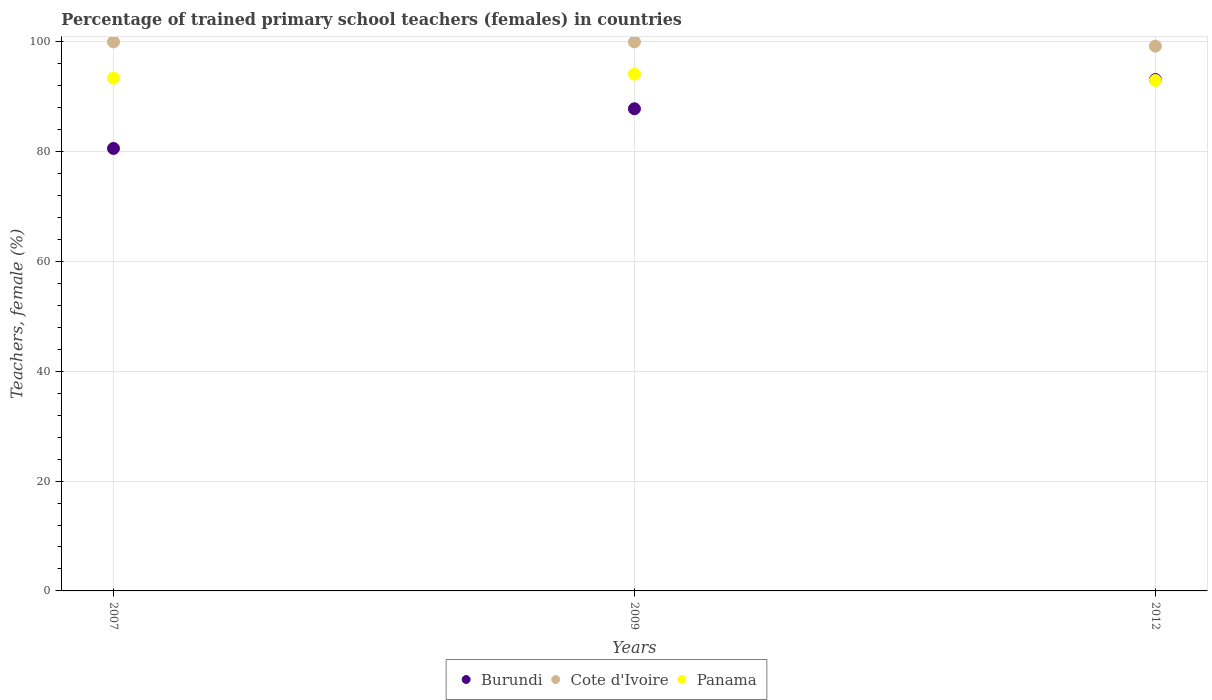How many different coloured dotlines are there?
Ensure brevity in your answer.  3. Is the number of dotlines equal to the number of legend labels?
Provide a short and direct response. Yes. What is the percentage of trained primary school teachers (females) in Panama in 2009?
Your response must be concise. 94.14. Across all years, what is the maximum percentage of trained primary school teachers (females) in Panama?
Give a very brief answer. 94.14. Across all years, what is the minimum percentage of trained primary school teachers (females) in Panama?
Keep it short and to the point. 92.97. In which year was the percentage of trained primary school teachers (females) in Burundi minimum?
Offer a very short reply. 2007. What is the total percentage of trained primary school teachers (females) in Cote d'Ivoire in the graph?
Give a very brief answer. 299.23. What is the difference between the percentage of trained primary school teachers (females) in Burundi in 2009 and that in 2012?
Your answer should be compact. -5.32. What is the difference between the percentage of trained primary school teachers (females) in Burundi in 2012 and the percentage of trained primary school teachers (females) in Panama in 2009?
Your response must be concise. -0.99. What is the average percentage of trained primary school teachers (females) in Panama per year?
Your response must be concise. 93.5. In the year 2012, what is the difference between the percentage of trained primary school teachers (females) in Burundi and percentage of trained primary school teachers (females) in Panama?
Ensure brevity in your answer.  0.18. In how many years, is the percentage of trained primary school teachers (females) in Panama greater than 48 %?
Your answer should be compact. 3. What is the ratio of the percentage of trained primary school teachers (females) in Cote d'Ivoire in 2009 to that in 2012?
Give a very brief answer. 1.01. Is the difference between the percentage of trained primary school teachers (females) in Burundi in 2007 and 2012 greater than the difference between the percentage of trained primary school teachers (females) in Panama in 2007 and 2012?
Your response must be concise. No. What is the difference between the highest and the second highest percentage of trained primary school teachers (females) in Burundi?
Your response must be concise. 5.32. What is the difference between the highest and the lowest percentage of trained primary school teachers (females) in Panama?
Keep it short and to the point. 1.17. Does the percentage of trained primary school teachers (females) in Burundi monotonically increase over the years?
Offer a very short reply. Yes. Is the percentage of trained primary school teachers (females) in Cote d'Ivoire strictly greater than the percentage of trained primary school teachers (females) in Panama over the years?
Provide a short and direct response. Yes. How many dotlines are there?
Provide a short and direct response. 3. Are the values on the major ticks of Y-axis written in scientific E-notation?
Offer a terse response. No. Does the graph contain any zero values?
Provide a short and direct response. No. Does the graph contain grids?
Provide a short and direct response. Yes. How are the legend labels stacked?
Provide a succinct answer. Horizontal. What is the title of the graph?
Your answer should be compact. Percentage of trained primary school teachers (females) in countries. What is the label or title of the Y-axis?
Offer a very short reply. Teachers, female (%). What is the Teachers, female (%) of Burundi in 2007?
Your answer should be very brief. 80.59. What is the Teachers, female (%) in Cote d'Ivoire in 2007?
Make the answer very short. 100. What is the Teachers, female (%) in Panama in 2007?
Provide a succinct answer. 93.39. What is the Teachers, female (%) of Burundi in 2009?
Provide a succinct answer. 87.82. What is the Teachers, female (%) of Panama in 2009?
Make the answer very short. 94.14. What is the Teachers, female (%) in Burundi in 2012?
Offer a terse response. 93.14. What is the Teachers, female (%) in Cote d'Ivoire in 2012?
Keep it short and to the point. 99.23. What is the Teachers, female (%) of Panama in 2012?
Make the answer very short. 92.97. Across all years, what is the maximum Teachers, female (%) of Burundi?
Ensure brevity in your answer.  93.14. Across all years, what is the maximum Teachers, female (%) of Cote d'Ivoire?
Keep it short and to the point. 100. Across all years, what is the maximum Teachers, female (%) in Panama?
Provide a succinct answer. 94.14. Across all years, what is the minimum Teachers, female (%) in Burundi?
Ensure brevity in your answer.  80.59. Across all years, what is the minimum Teachers, female (%) of Cote d'Ivoire?
Give a very brief answer. 99.23. Across all years, what is the minimum Teachers, female (%) in Panama?
Give a very brief answer. 92.97. What is the total Teachers, female (%) in Burundi in the graph?
Offer a very short reply. 261.56. What is the total Teachers, female (%) in Cote d'Ivoire in the graph?
Offer a terse response. 299.23. What is the total Teachers, female (%) in Panama in the graph?
Make the answer very short. 280.49. What is the difference between the Teachers, female (%) in Burundi in 2007 and that in 2009?
Your answer should be compact. -7.23. What is the difference between the Teachers, female (%) of Panama in 2007 and that in 2009?
Your answer should be compact. -0.75. What is the difference between the Teachers, female (%) of Burundi in 2007 and that in 2012?
Your answer should be very brief. -12.55. What is the difference between the Teachers, female (%) of Cote d'Ivoire in 2007 and that in 2012?
Make the answer very short. 0.77. What is the difference between the Teachers, female (%) of Panama in 2007 and that in 2012?
Give a very brief answer. 0.42. What is the difference between the Teachers, female (%) of Burundi in 2009 and that in 2012?
Offer a very short reply. -5.32. What is the difference between the Teachers, female (%) in Cote d'Ivoire in 2009 and that in 2012?
Provide a succinct answer. 0.77. What is the difference between the Teachers, female (%) in Panama in 2009 and that in 2012?
Offer a very short reply. 1.17. What is the difference between the Teachers, female (%) of Burundi in 2007 and the Teachers, female (%) of Cote d'Ivoire in 2009?
Your answer should be compact. -19.41. What is the difference between the Teachers, female (%) in Burundi in 2007 and the Teachers, female (%) in Panama in 2009?
Make the answer very short. -13.54. What is the difference between the Teachers, female (%) of Cote d'Ivoire in 2007 and the Teachers, female (%) of Panama in 2009?
Give a very brief answer. 5.86. What is the difference between the Teachers, female (%) in Burundi in 2007 and the Teachers, female (%) in Cote d'Ivoire in 2012?
Your response must be concise. -18.63. What is the difference between the Teachers, female (%) of Burundi in 2007 and the Teachers, female (%) of Panama in 2012?
Offer a terse response. -12.38. What is the difference between the Teachers, female (%) of Cote d'Ivoire in 2007 and the Teachers, female (%) of Panama in 2012?
Keep it short and to the point. 7.03. What is the difference between the Teachers, female (%) of Burundi in 2009 and the Teachers, female (%) of Cote d'Ivoire in 2012?
Your answer should be very brief. -11.41. What is the difference between the Teachers, female (%) in Burundi in 2009 and the Teachers, female (%) in Panama in 2012?
Your answer should be very brief. -5.15. What is the difference between the Teachers, female (%) of Cote d'Ivoire in 2009 and the Teachers, female (%) of Panama in 2012?
Keep it short and to the point. 7.03. What is the average Teachers, female (%) of Burundi per year?
Keep it short and to the point. 87.19. What is the average Teachers, female (%) in Cote d'Ivoire per year?
Your answer should be very brief. 99.74. What is the average Teachers, female (%) of Panama per year?
Provide a short and direct response. 93.5. In the year 2007, what is the difference between the Teachers, female (%) of Burundi and Teachers, female (%) of Cote d'Ivoire?
Ensure brevity in your answer.  -19.41. In the year 2007, what is the difference between the Teachers, female (%) of Burundi and Teachers, female (%) of Panama?
Offer a terse response. -12.79. In the year 2007, what is the difference between the Teachers, female (%) in Cote d'Ivoire and Teachers, female (%) in Panama?
Your response must be concise. 6.61. In the year 2009, what is the difference between the Teachers, female (%) in Burundi and Teachers, female (%) in Cote d'Ivoire?
Your answer should be very brief. -12.18. In the year 2009, what is the difference between the Teachers, female (%) of Burundi and Teachers, female (%) of Panama?
Offer a very short reply. -6.32. In the year 2009, what is the difference between the Teachers, female (%) of Cote d'Ivoire and Teachers, female (%) of Panama?
Offer a very short reply. 5.86. In the year 2012, what is the difference between the Teachers, female (%) in Burundi and Teachers, female (%) in Cote d'Ivoire?
Give a very brief answer. -6.08. In the year 2012, what is the difference between the Teachers, female (%) in Burundi and Teachers, female (%) in Panama?
Make the answer very short. 0.18. In the year 2012, what is the difference between the Teachers, female (%) of Cote d'Ivoire and Teachers, female (%) of Panama?
Your answer should be compact. 6.26. What is the ratio of the Teachers, female (%) of Burundi in 2007 to that in 2009?
Provide a succinct answer. 0.92. What is the ratio of the Teachers, female (%) of Cote d'Ivoire in 2007 to that in 2009?
Offer a terse response. 1. What is the ratio of the Teachers, female (%) in Panama in 2007 to that in 2009?
Give a very brief answer. 0.99. What is the ratio of the Teachers, female (%) of Burundi in 2007 to that in 2012?
Offer a very short reply. 0.87. What is the ratio of the Teachers, female (%) in Cote d'Ivoire in 2007 to that in 2012?
Provide a succinct answer. 1.01. What is the ratio of the Teachers, female (%) in Panama in 2007 to that in 2012?
Keep it short and to the point. 1. What is the ratio of the Teachers, female (%) of Burundi in 2009 to that in 2012?
Give a very brief answer. 0.94. What is the ratio of the Teachers, female (%) in Panama in 2009 to that in 2012?
Your answer should be very brief. 1.01. What is the difference between the highest and the second highest Teachers, female (%) in Burundi?
Offer a very short reply. 5.32. What is the difference between the highest and the second highest Teachers, female (%) of Panama?
Your response must be concise. 0.75. What is the difference between the highest and the lowest Teachers, female (%) in Burundi?
Your answer should be very brief. 12.55. What is the difference between the highest and the lowest Teachers, female (%) of Cote d'Ivoire?
Give a very brief answer. 0.77. What is the difference between the highest and the lowest Teachers, female (%) of Panama?
Provide a short and direct response. 1.17. 